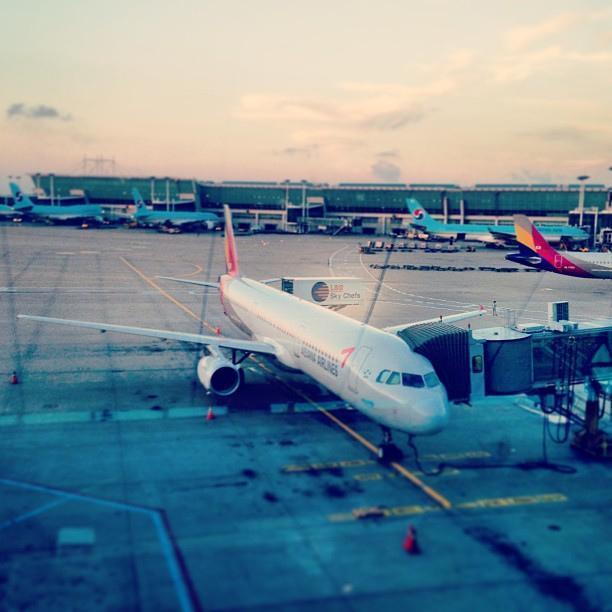How many planes are pictured?
Give a very brief answer. 5. How many airplanes can you see?
Give a very brief answer. 3. How many people are in the picture?
Give a very brief answer. 0. 